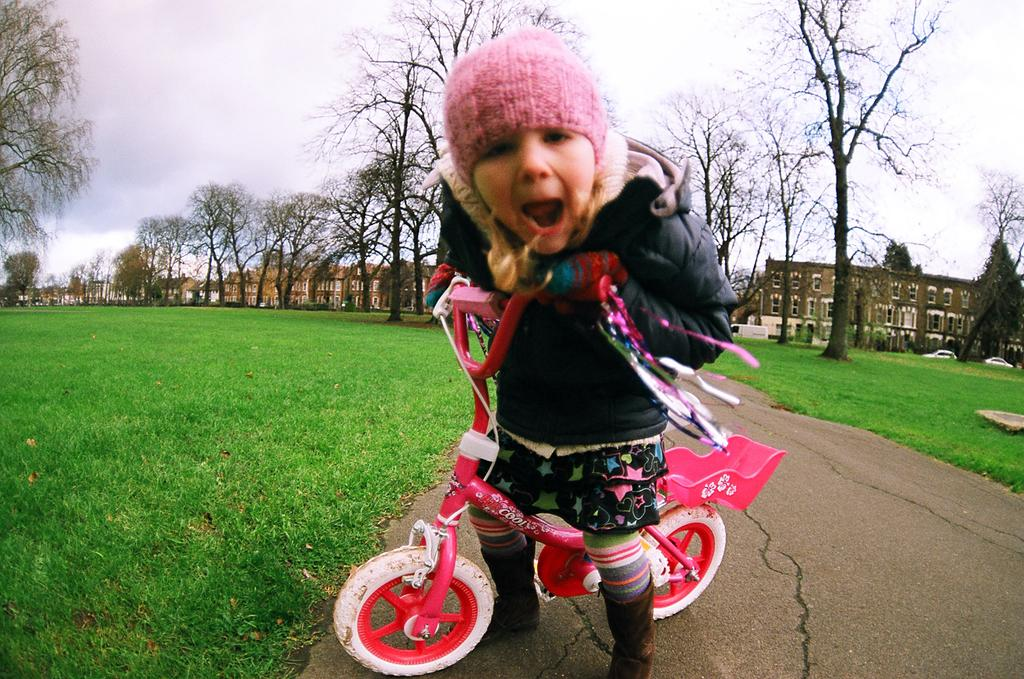What is the main subject of the image? The main subject of the image is a kid. What is the kid holding in the image? The kid is holding a bicycle. What can be seen in the background of the image? There are trees, buildings, and the sky visible in the background of the image. Can you see a rabbit hopping on a hill in the image? There is no hill or rabbit present in the image. 